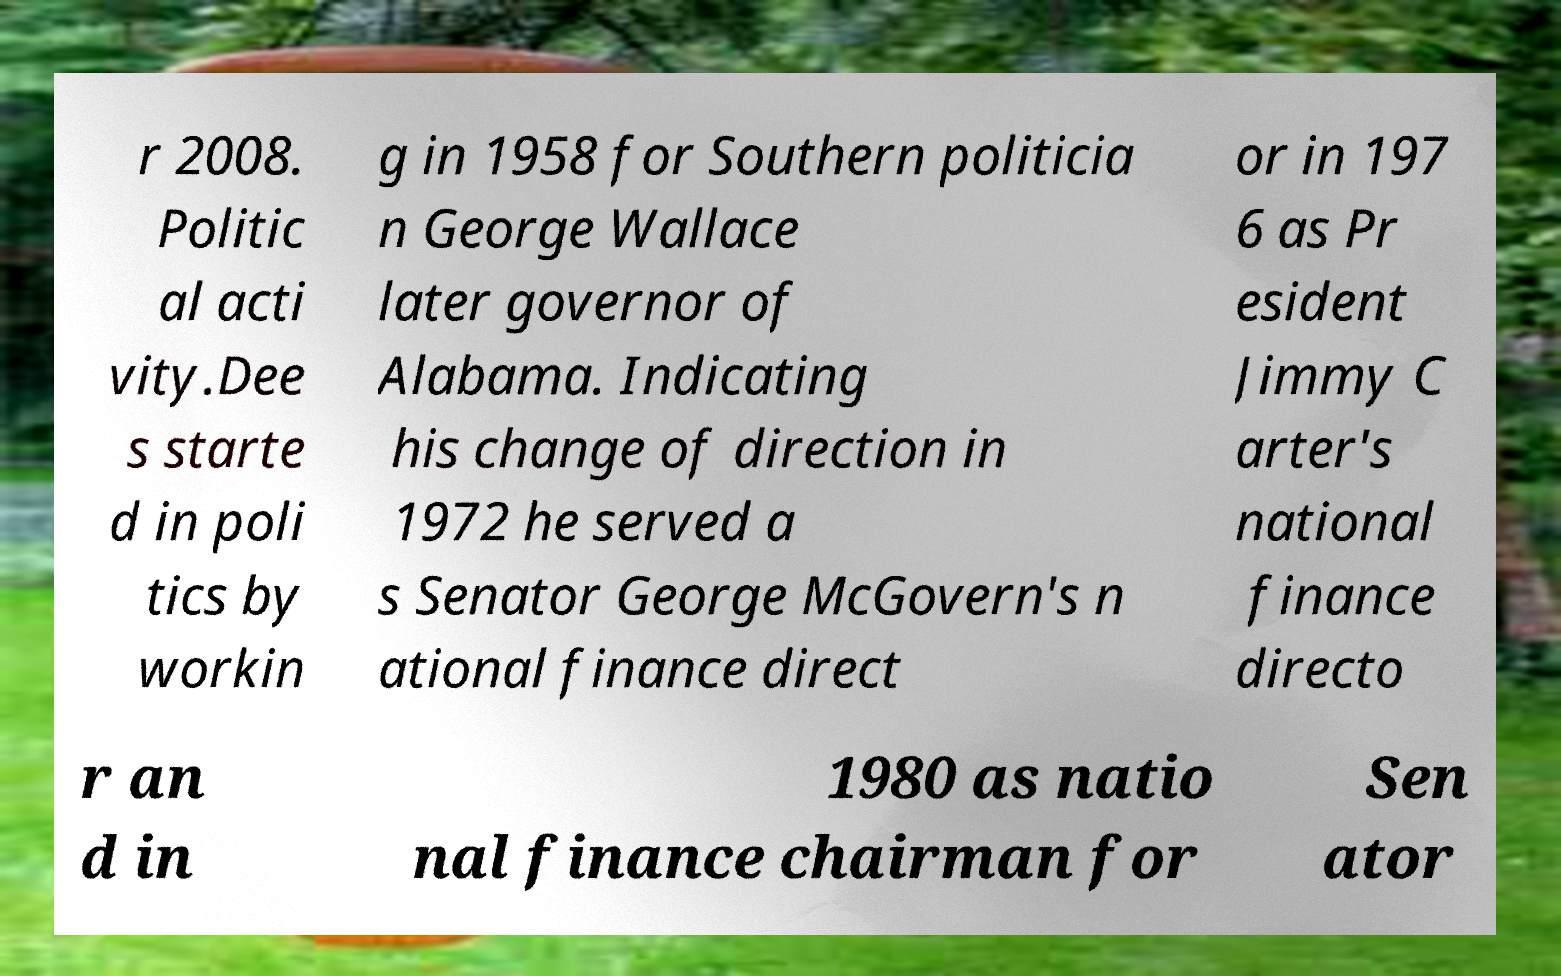Please identify and transcribe the text found in this image. r 2008. Politic al acti vity.Dee s starte d in poli tics by workin g in 1958 for Southern politicia n George Wallace later governor of Alabama. Indicating his change of direction in 1972 he served a s Senator George McGovern's n ational finance direct or in 197 6 as Pr esident Jimmy C arter's national finance directo r an d in 1980 as natio nal finance chairman for Sen ator 